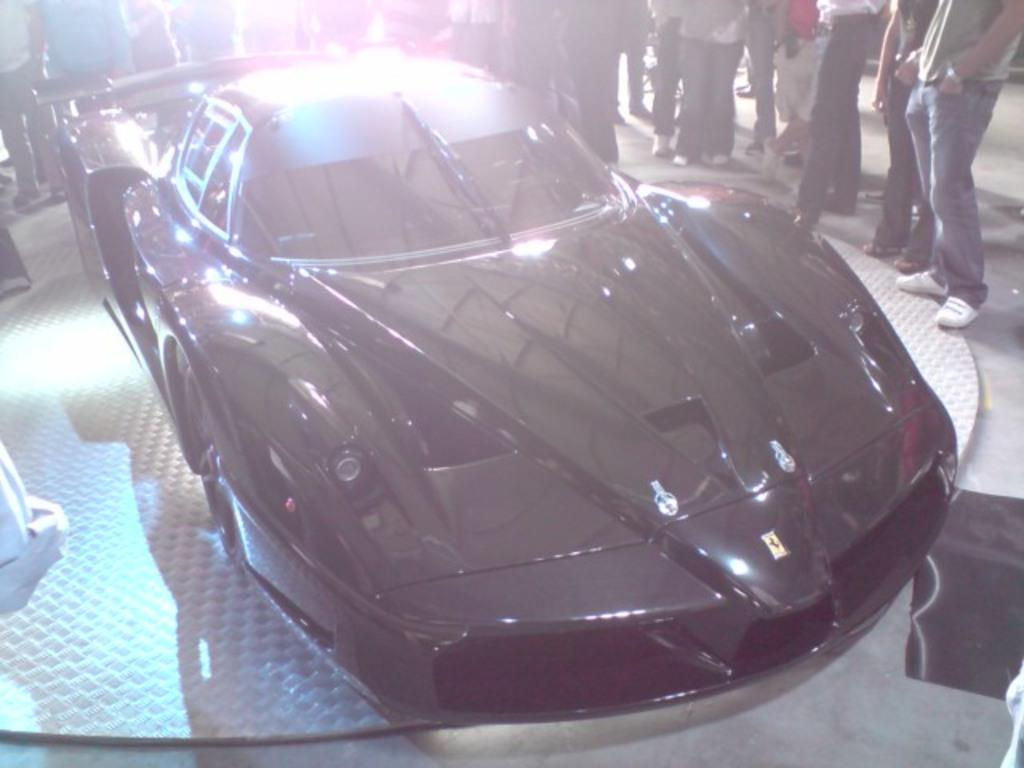What color is the car in the image? The car in the image is black. What can be seen around the car? There are people standing around the car. Is there any sleet visible on the car in the image? There is no mention of sleet in the provided facts, and it cannot be determined from the image if there is any sleet present. 